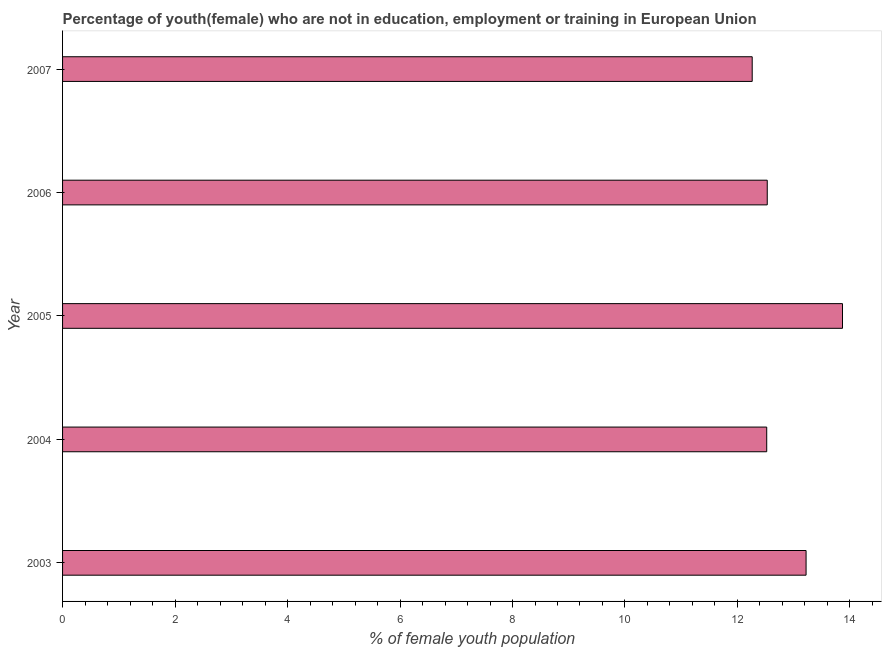Does the graph contain any zero values?
Provide a succinct answer. No. Does the graph contain grids?
Provide a succinct answer. No. What is the title of the graph?
Offer a very short reply. Percentage of youth(female) who are not in education, employment or training in European Union. What is the label or title of the X-axis?
Offer a very short reply. % of female youth population. What is the unemployed female youth population in 2007?
Keep it short and to the point. 12.26. Across all years, what is the maximum unemployed female youth population?
Keep it short and to the point. 13.87. Across all years, what is the minimum unemployed female youth population?
Offer a very short reply. 12.26. In which year was the unemployed female youth population maximum?
Give a very brief answer. 2005. What is the sum of the unemployed female youth population?
Your answer should be very brief. 64.4. What is the difference between the unemployed female youth population in 2004 and 2005?
Provide a short and direct response. -1.35. What is the average unemployed female youth population per year?
Offer a terse response. 12.88. What is the median unemployed female youth population?
Your response must be concise. 12.53. In how many years, is the unemployed female youth population greater than 11.2 %?
Ensure brevity in your answer.  5. What is the ratio of the unemployed female youth population in 2003 to that in 2005?
Keep it short and to the point. 0.95. Is the difference between the unemployed female youth population in 2003 and 2004 greater than the difference between any two years?
Your response must be concise. No. What is the difference between the highest and the second highest unemployed female youth population?
Offer a very short reply. 0.65. What is the difference between the highest and the lowest unemployed female youth population?
Give a very brief answer. 1.61. What is the difference between two consecutive major ticks on the X-axis?
Ensure brevity in your answer.  2. What is the % of female youth population of 2003?
Your response must be concise. 13.22. What is the % of female youth population of 2004?
Offer a very short reply. 12.52. What is the % of female youth population in 2005?
Your answer should be compact. 13.87. What is the % of female youth population in 2006?
Offer a very short reply. 12.53. What is the % of female youth population in 2007?
Keep it short and to the point. 12.26. What is the difference between the % of female youth population in 2003 and 2004?
Provide a succinct answer. 0.7. What is the difference between the % of female youth population in 2003 and 2005?
Your answer should be compact. -0.65. What is the difference between the % of female youth population in 2003 and 2006?
Give a very brief answer. 0.69. What is the difference between the % of female youth population in 2003 and 2007?
Ensure brevity in your answer.  0.96. What is the difference between the % of female youth population in 2004 and 2005?
Provide a short and direct response. -1.35. What is the difference between the % of female youth population in 2004 and 2006?
Your answer should be very brief. -0.01. What is the difference between the % of female youth population in 2004 and 2007?
Offer a terse response. 0.26. What is the difference between the % of female youth population in 2005 and 2006?
Your response must be concise. 1.34. What is the difference between the % of female youth population in 2005 and 2007?
Make the answer very short. 1.61. What is the difference between the % of female youth population in 2006 and 2007?
Offer a terse response. 0.27. What is the ratio of the % of female youth population in 2003 to that in 2004?
Ensure brevity in your answer.  1.06. What is the ratio of the % of female youth population in 2003 to that in 2005?
Your answer should be very brief. 0.95. What is the ratio of the % of female youth population in 2003 to that in 2006?
Your answer should be very brief. 1.05. What is the ratio of the % of female youth population in 2003 to that in 2007?
Make the answer very short. 1.08. What is the ratio of the % of female youth population in 2004 to that in 2005?
Make the answer very short. 0.9. What is the ratio of the % of female youth population in 2004 to that in 2006?
Keep it short and to the point. 1. What is the ratio of the % of female youth population in 2005 to that in 2006?
Give a very brief answer. 1.11. What is the ratio of the % of female youth population in 2005 to that in 2007?
Ensure brevity in your answer.  1.13. 